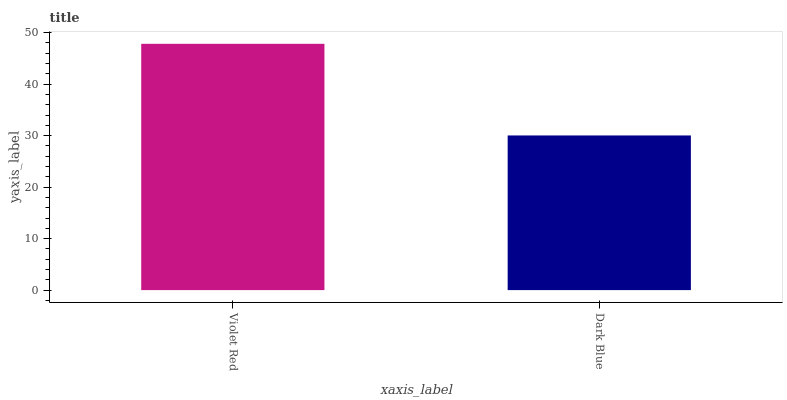Is Dark Blue the minimum?
Answer yes or no. Yes. Is Violet Red the maximum?
Answer yes or no. Yes. Is Dark Blue the maximum?
Answer yes or no. No. Is Violet Red greater than Dark Blue?
Answer yes or no. Yes. Is Dark Blue less than Violet Red?
Answer yes or no. Yes. Is Dark Blue greater than Violet Red?
Answer yes or no. No. Is Violet Red less than Dark Blue?
Answer yes or no. No. Is Violet Red the high median?
Answer yes or no. Yes. Is Dark Blue the low median?
Answer yes or no. Yes. Is Dark Blue the high median?
Answer yes or no. No. Is Violet Red the low median?
Answer yes or no. No. 